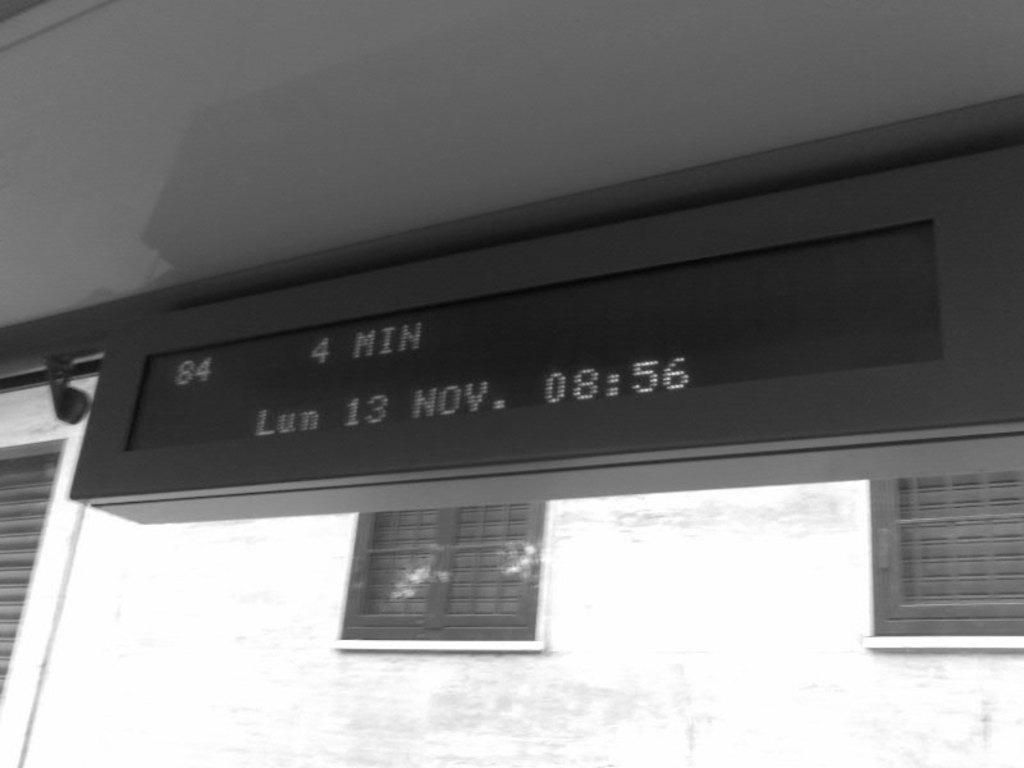What type of display is present in the image? There is an LCD display in the image. Where is the LCD display located in the image? The LCD display is at the top of the image. What can be seen in the background of the image? There are two windows in the background of the image. What is the windows' location in relation to the image? The windows are on a wall. What is to the left of the image? There is a shutter to the left of the image. How is the image presented in terms of color? The image is black and white. What type of cushion is placed on the table in the image? There is no cushion present in the image. What kind of meat is being prepared in the image? There is no meat or meal preparation visible in the image. 